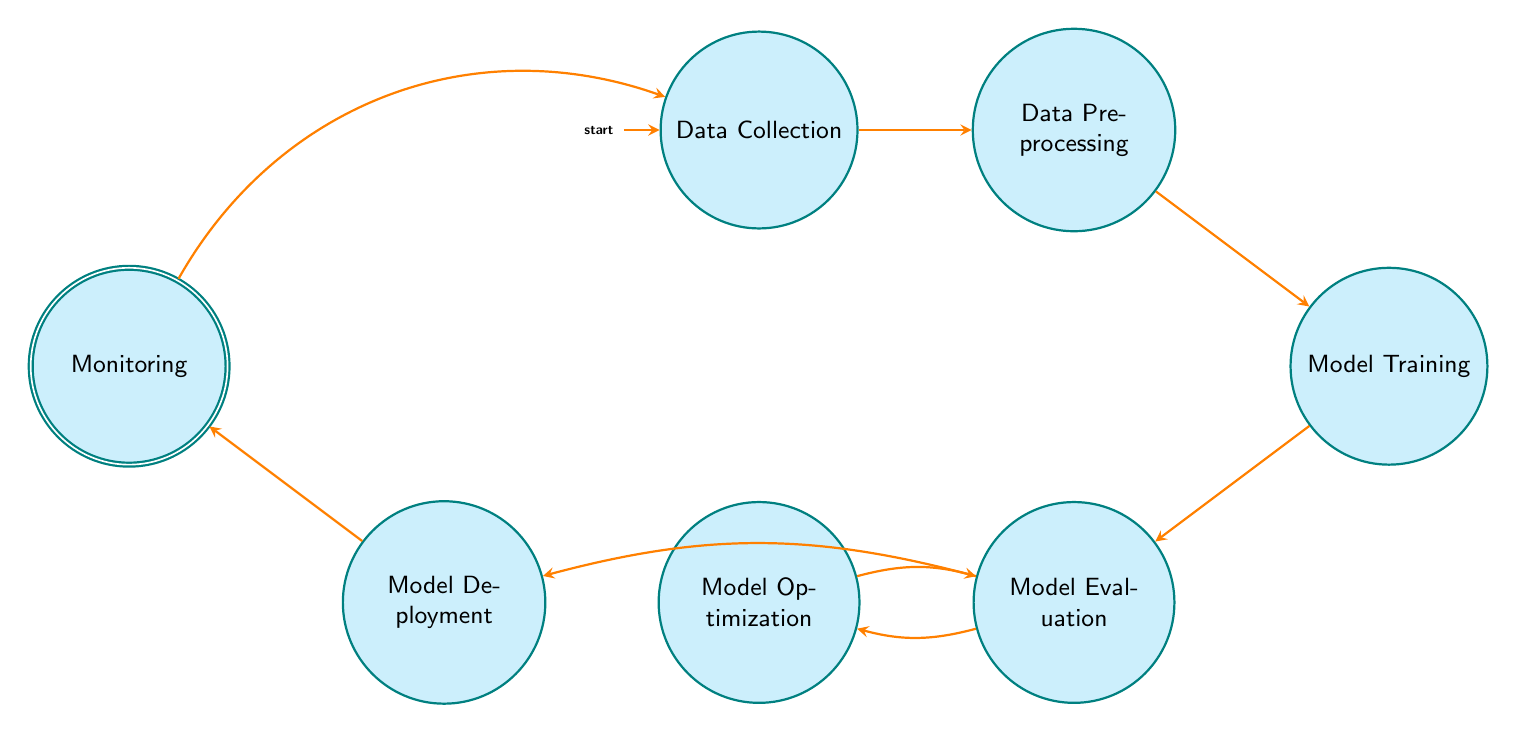What is the initial state of the Finite State Machine? According to the diagram, the initial state is indicated by the arrow pointing to the "Data Collection" node. Thus, this is the state where the lifecycle begins.
Answer: Data Collection How many transitions are there from the "Model Evaluation" node? The diagram shows that the "Model Evaluation" node has two outgoing transitions: one to "Model Optimization" and another to "Model Deployment". Therefore, the count of transitions from this node is two.
Answer: 2 What is the final state in the machine learning model deployment lifecycle? The final state is marked by the double circle around the "Monitoring" node, indicating that this is the concluding phase of the lifecycle process.
Answer: Monitoring Which state comes after "Model Training"? The diagram clearly shows an arrow going from "Model Training" to "Model Evaluation", indicating that "Model Evaluation" is the next step in the sequence after "Model Training".
Answer: Model Evaluation Why can’t the lifecycle directly transition from "Model Evaluation" to "Monitoring"? The diagram indicates that "Model Evaluation" can transition to either "Model Optimization" or "Model Deployment", but not directly to "Monitoring". This suggests that a model must either be optimized or deployed before entering the monitoring stage.
Answer: Because it requires an intermediary step What is the relationship between "Model Optimization" and "Model Evaluation"? The diagram shows that there is a cycle between "Model Optimization" and "Model Evaluation", meaning after optimization, it leads back to evaluating the model performance, thus indicating a feedback loop for continuous improvement.
Answer: Feedback loop How many total states are there in this Finite State Machine? The states listed in the data are: "Data Collection", "Data Preprocessing", "Model Training", "Model Evaluation", "Model Optimization", "Model Deployment", and "Monitoring". Counting these gives a total of seven distinct states.
Answer: 7 In which stage is the accuracy of the flagging system monitored? The diagram shows that "Monitoring" is the stage dedicated to observing the model performance and flagging system accuracy, indicated by its direct transition from "Model Deployment".
Answer: Monitoring What action follows the "Model Deployment" state? The state diagram indicates that after "Model Deployment", the lifecycle moves directly to "Monitoring", showing that this is the next logical step after deploying the model.
Answer: Monitoring 